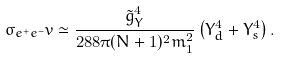<formula> <loc_0><loc_0><loc_500><loc_500>\sigma _ { e ^ { + } e ^ { - } } v \simeq \frac { \tilde { g } _ { Y } ^ { 4 } } { 2 8 8 \pi ( N + 1 ) ^ { 2 } m _ { 1 } ^ { 2 } } \left ( Y _ { d } ^ { 4 } + Y _ { s } ^ { 4 } \right ) .</formula> 